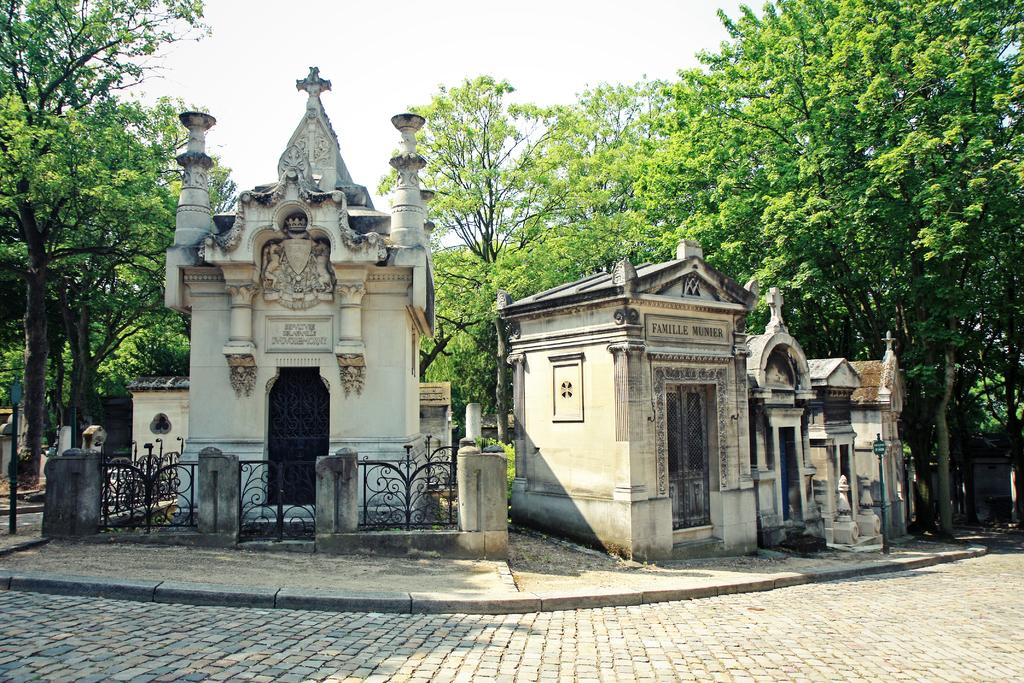What is the main subject in the center of the image? There are buildings in the center of the image. What can be seen in the background of the image? There are trees in the background of the image. What is in front of the building? There is a black fence in front of the building. How would you describe the sky in the image? The sky is cloudy. Can you tell me how many stars are visible in the image? There are no stars visible in the image; the sky is cloudy. Is there a snail crawling on the black fence in the image? There is no snail present in the image; only the black fence is visible. 